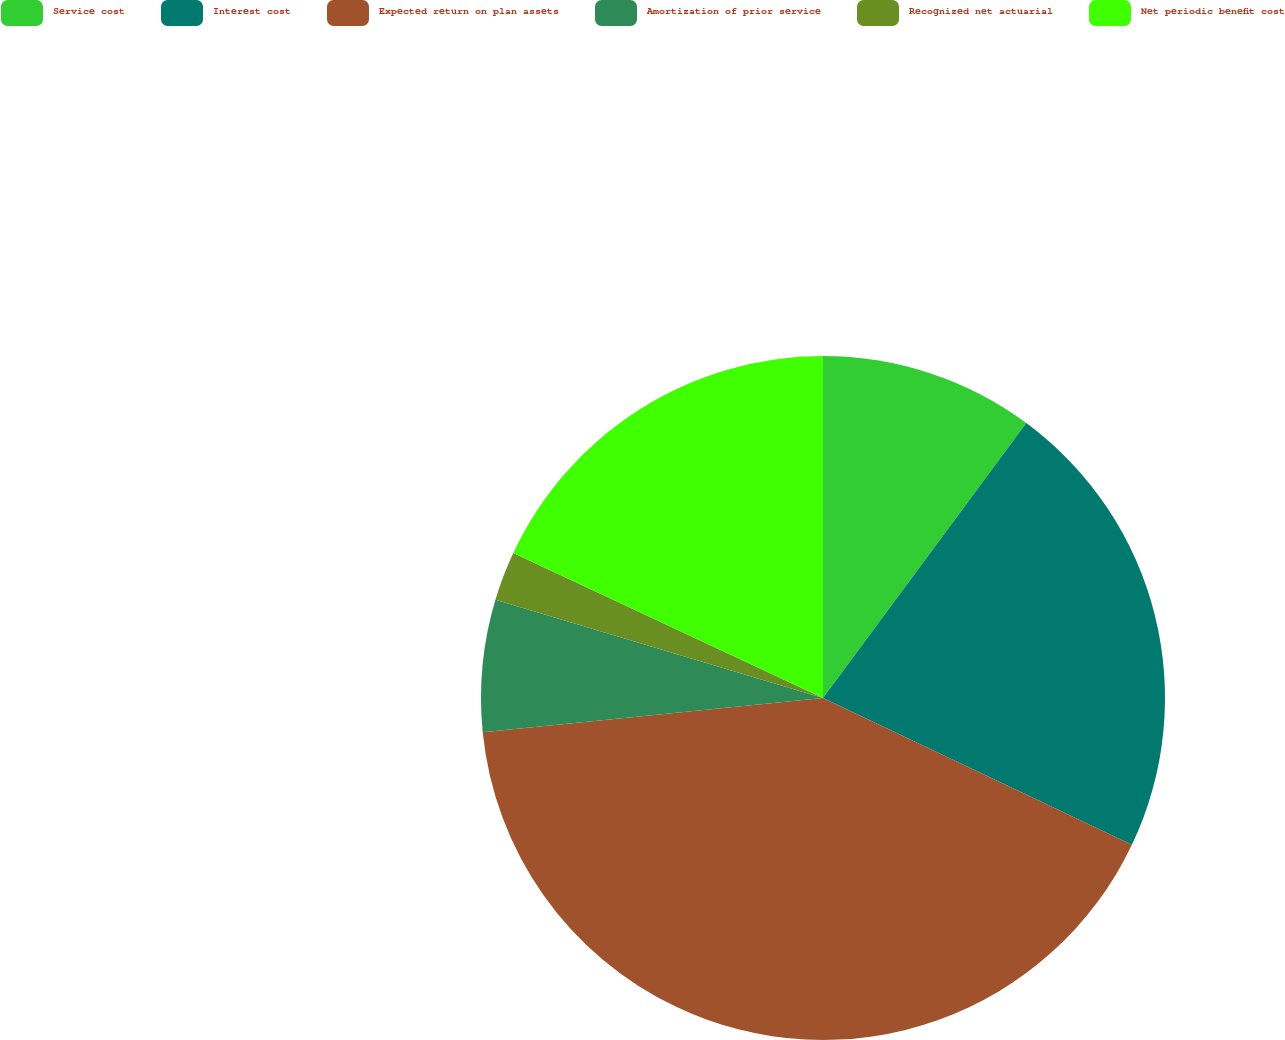Convert chart. <chart><loc_0><loc_0><loc_500><loc_500><pie_chart><fcel>Service cost<fcel>Interest cost<fcel>Expected return on plan assets<fcel>Amortization of prior service<fcel>Recognized net actuarial<fcel>Net periodic benefit cost<nl><fcel>10.13%<fcel>21.93%<fcel>41.34%<fcel>6.23%<fcel>2.33%<fcel>18.03%<nl></chart> 